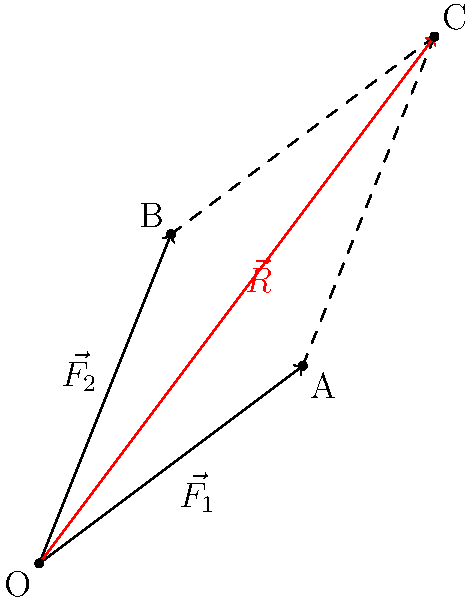As a stand-up comedian who admires paramedics, you're doing a bit about their superhuman strength. Two paramedics are carrying a stretcher, applying forces $\vec{F_1} = 4\hat{i} + 3\hat{j}$ and $\vec{F_2} = 2\hat{i} + 5\hat{j}$ (in Newtons). What's the magnitude of the resultant force vector $\vec{R}$ acting on the stretcher? Round your answer to the nearest whole number. Let's approach this step-by-step:

1) The resultant vector $\vec{R}$ is the sum of the two force vectors:
   $\vec{R} = \vec{F_1} + \vec{F_2}$

2) Let's add the components:
   $\vec{R} = (4\hat{i} + 3\hat{j}) + (2\hat{i} + 5\hat{j})$
   $\vec{R} = (4+2)\hat{i} + (3+5)\hat{j}$
   $\vec{R} = 6\hat{i} + 8\hat{j}$

3) To find the magnitude of $\vec{R}$, we use the Pythagorean theorem:
   $|\vec{R}| = \sqrt{6^2 + 8^2}$

4) Calculate:
   $|\vec{R}| = \sqrt{36 + 64} = \sqrt{100} = 10$

5) The question asks to round to the nearest whole number, but 10 is already a whole number.

Therefore, the magnitude of the resultant force vector is 10 Newtons.
Answer: 10 N 